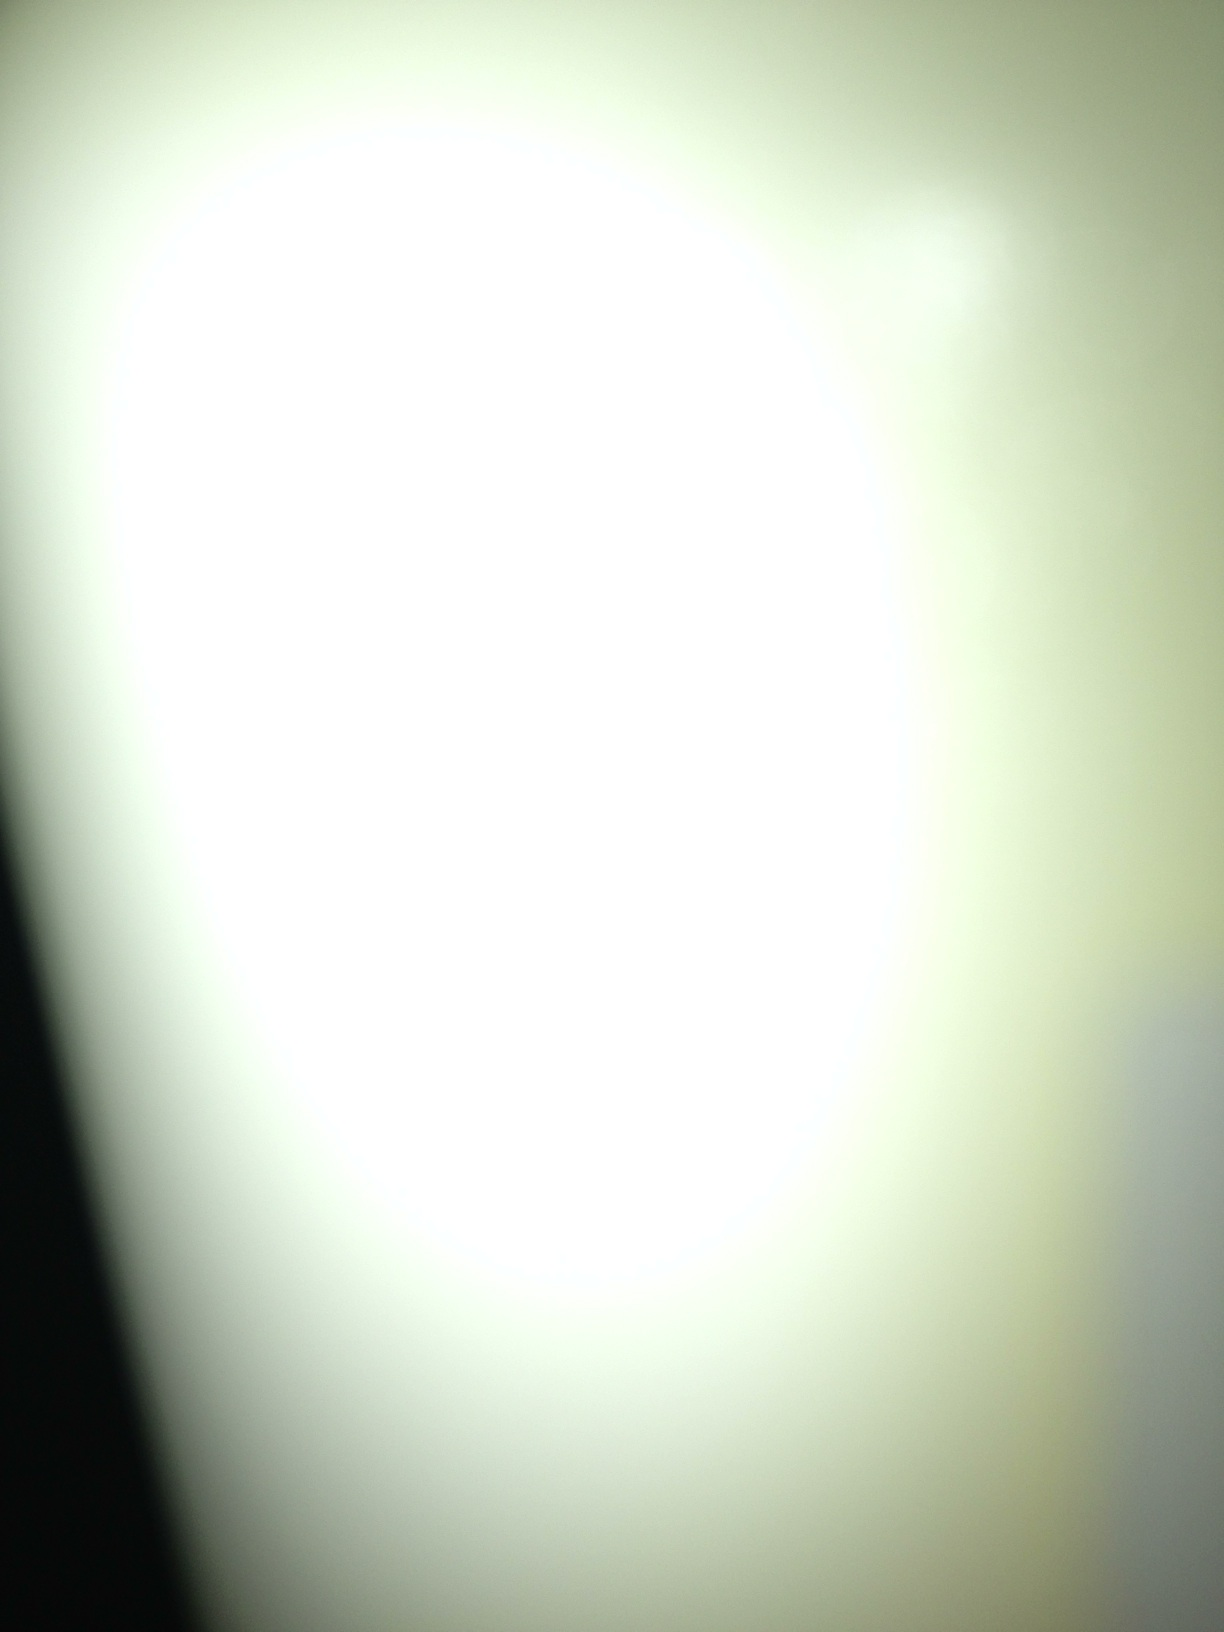Is this image related to any known artistic style or movement? This image could be associated with abstract expressionism, a movement popularized in the mid-20th century which emphasizes spontaneous, automatic, or subconscious creation. Artists like Jackson Pollock and Mark Rothko created artworks that may not depict concrete objects but evoke emotions and ideas through forms and colors. 